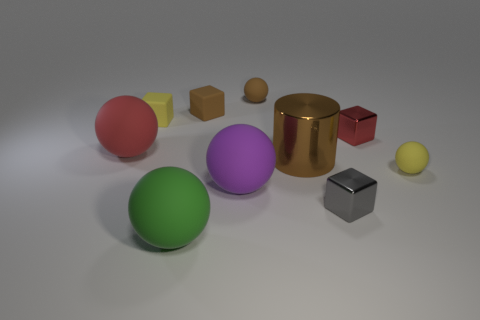Are there any tiny gray objects that have the same material as the large purple object?
Ensure brevity in your answer.  No. Are there any large purple rubber things that are to the right of the block that is in front of the red object that is to the left of the large green thing?
Your answer should be very brief. No. What shape is the red metallic object that is the same size as the gray object?
Keep it short and to the point. Cube. There is a yellow matte object that is right of the green thing; does it have the same size as the red thing on the right side of the large purple matte sphere?
Keep it short and to the point. Yes. How many metallic cubes are there?
Keep it short and to the point. 2. How big is the shiny object in front of the big sphere right of the matte ball in front of the gray object?
Your answer should be compact. Small. Is there any other thing that is the same size as the yellow matte ball?
Keep it short and to the point. Yes. How many green matte balls are to the right of the gray metal thing?
Your answer should be compact. 0. Are there the same number of red shiny cubes behind the small brown rubber cube and big green rubber cylinders?
Ensure brevity in your answer.  Yes. How many things are large red spheres or big green cylinders?
Make the answer very short. 1. 